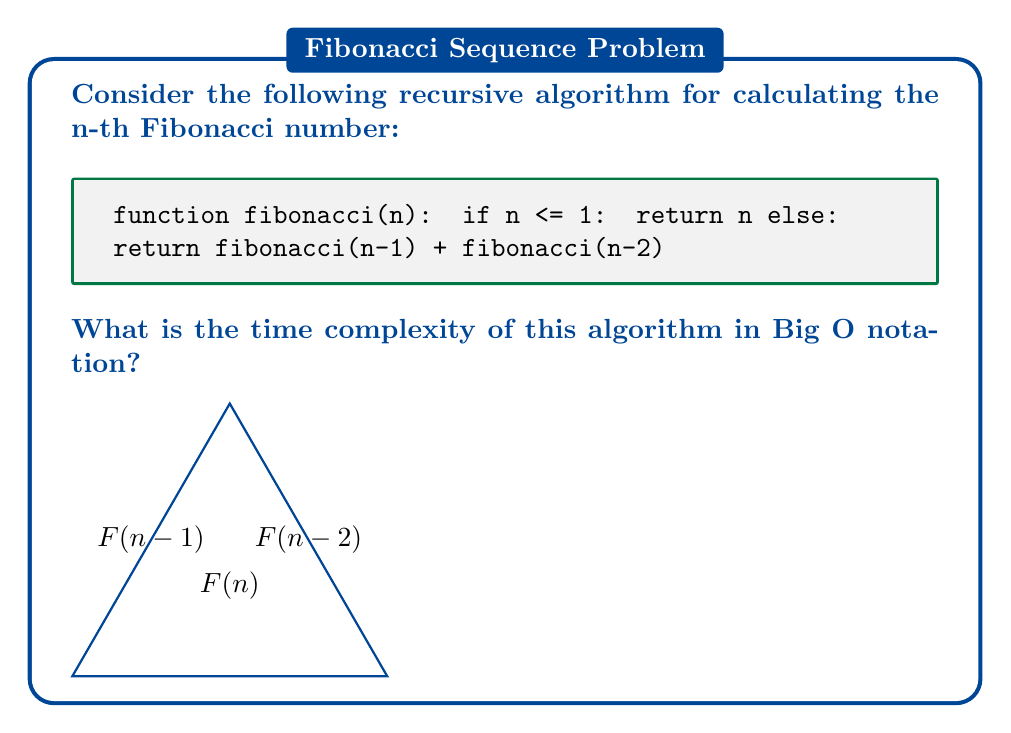Help me with this question. To determine the time complexity of this recursive Fibonacci algorithm, we need to analyze its recursive structure:

1. Base case: When $n \leq 1$, the function returns immediately. This takes constant time, $O(1)$.

2. Recursive case: For $n > 1$, the function makes two recursive calls:
   - $fibonacci(n-1)$
   - $fibonacci(n-2)$

3. Let $T(n)$ be the time complexity for input $n$. We can express this as a recurrence relation:
   $$T(n) = T(n-1) + T(n-2) + O(1)$$

4. This recurrence is similar to the Fibonacci sequence itself, which grows exponentially.

5. The solution to this recurrence is approximately:
   $$T(n) \approx \left(\frac{1+\sqrt{5}}{2}\right)^n$$

6. The value $\frac{1+\sqrt{5}}{2} \approx 1.618$ is known as the golden ratio, often denoted by $\phi$.

7. In Big O notation, we can express this as $O(\phi^n)$.

8. Since $\phi^n \approx (1.618)^n$, we can also express this as $O(1.618^n)$ or more generally as $O(2^n)$.

Therefore, the time complexity of this recursive Fibonacci algorithm is exponential.
Answer: $O(2^n)$ 